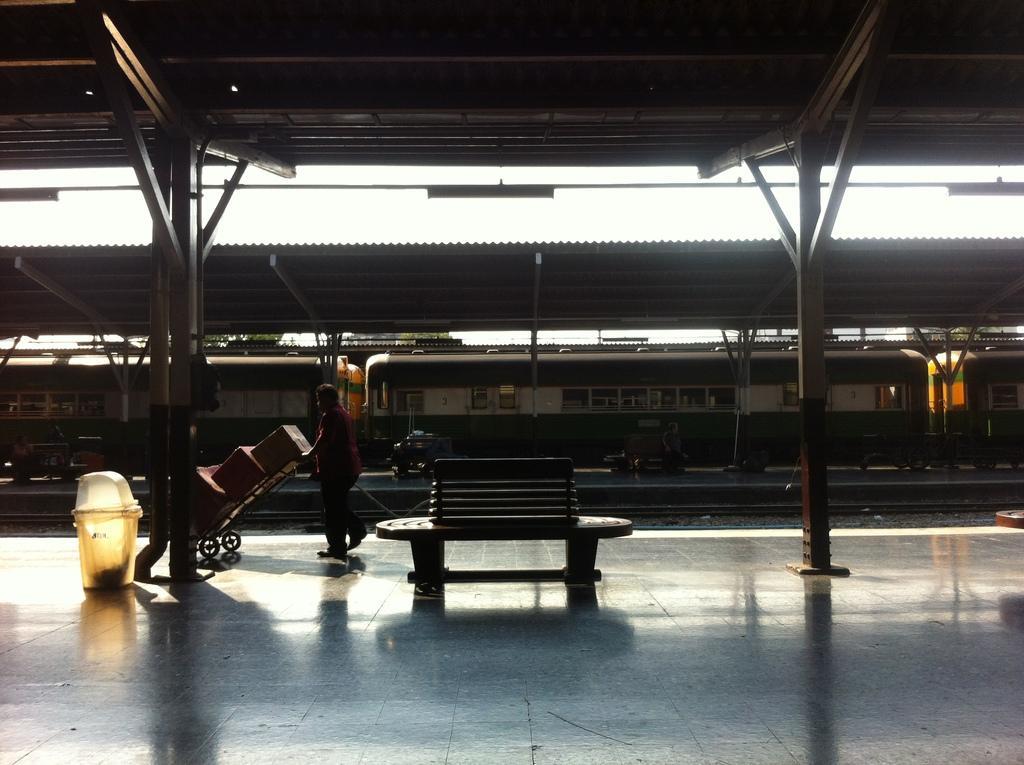Could you give a brief overview of what you see in this image? This image consists of a railway station in which there is a train. At the top, there is a shed. At the bottom, there is a platform along with a bench and a dustbin. In the front, there is a man holding a trolley. 